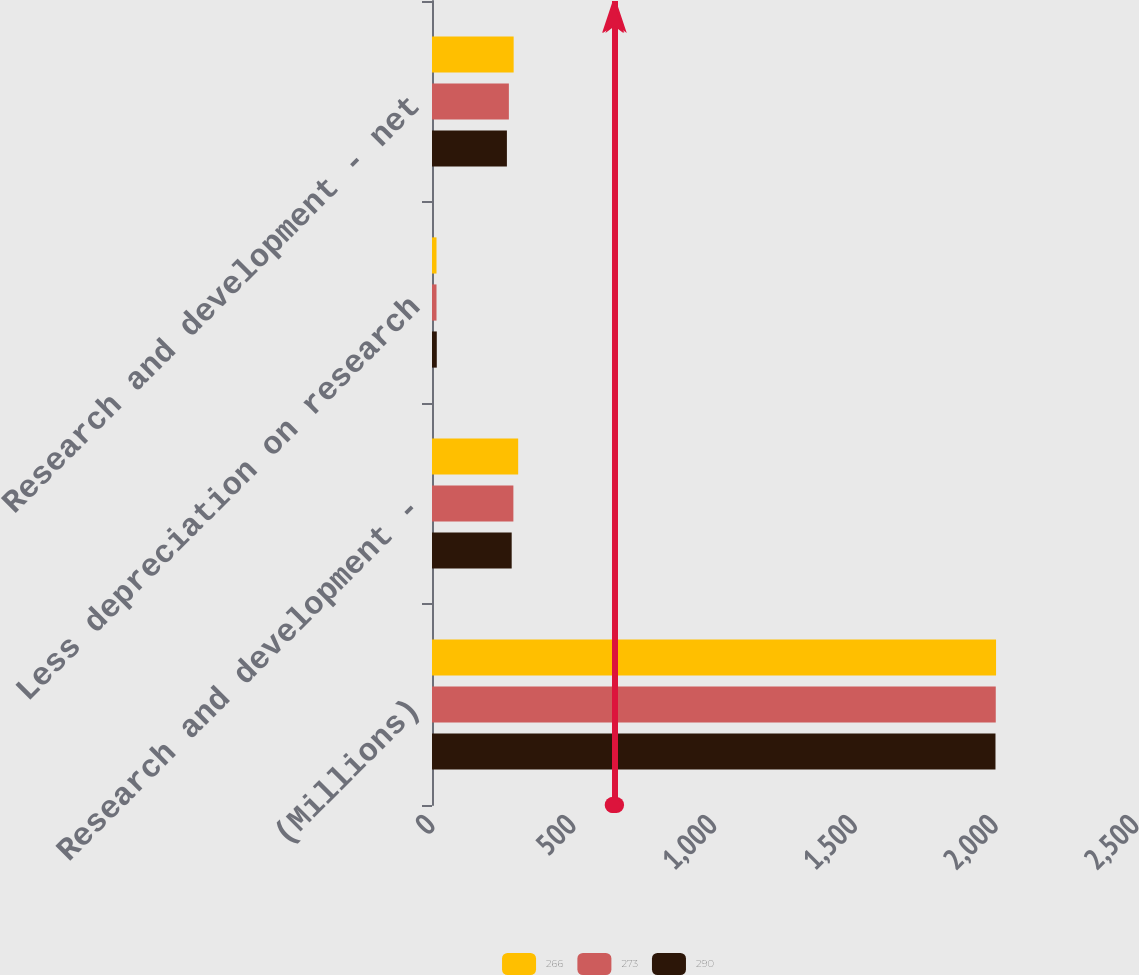<chart> <loc_0><loc_0><loc_500><loc_500><stacked_bar_chart><ecel><fcel>(Millions)<fcel>Research and development -<fcel>Less depreciation on research<fcel>Research and development - net<nl><fcel>266<fcel>2003<fcel>306<fcel>16<fcel>290<nl><fcel>273<fcel>2002<fcel>289<fcel>16<fcel>273<nl><fcel>290<fcel>2001<fcel>283<fcel>17<fcel>266<nl></chart> 